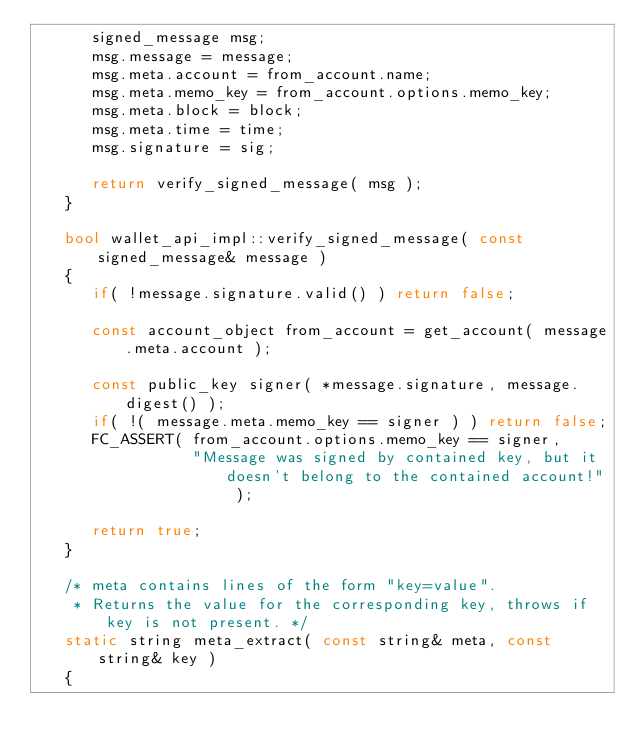<code> <loc_0><loc_0><loc_500><loc_500><_C++_>      signed_message msg;
      msg.message = message;
      msg.meta.account = from_account.name;
      msg.meta.memo_key = from_account.options.memo_key;
      msg.meta.block = block;
      msg.meta.time = time;
      msg.signature = sig;

      return verify_signed_message( msg );
   }

   bool wallet_api_impl::verify_signed_message( const signed_message& message )
   {
      if( !message.signature.valid() ) return false;

      const account_object from_account = get_account( message.meta.account );

      const public_key signer( *message.signature, message.digest() );
      if( !( message.meta.memo_key == signer ) ) return false;
      FC_ASSERT( from_account.options.memo_key == signer,
                 "Message was signed by contained key, but it doesn't belong to the contained account!" );

      return true;
   }

   /* meta contains lines of the form "key=value".
    * Returns the value for the corresponding key, throws if key is not present. */
   static string meta_extract( const string& meta, const string& key )
   {</code> 